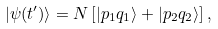Convert formula to latex. <formula><loc_0><loc_0><loc_500><loc_500>| \psi ( t ^ { \prime } ) \rangle = N \left [ | p _ { 1 } q _ { 1 } \rangle + | p _ { 2 } q _ { 2 } \rangle \right ] ,</formula> 